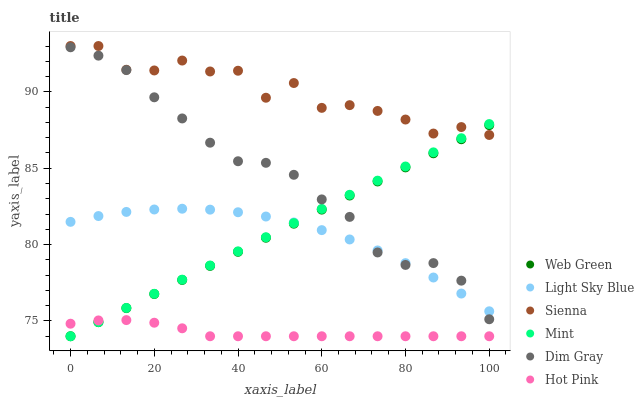Does Hot Pink have the minimum area under the curve?
Answer yes or no. Yes. Does Sienna have the maximum area under the curve?
Answer yes or no. Yes. Does Web Green have the minimum area under the curve?
Answer yes or no. No. Does Web Green have the maximum area under the curve?
Answer yes or no. No. Is Web Green the smoothest?
Answer yes or no. Yes. Is Sienna the roughest?
Answer yes or no. Yes. Is Hot Pink the smoothest?
Answer yes or no. No. Is Hot Pink the roughest?
Answer yes or no. No. Does Hot Pink have the lowest value?
Answer yes or no. Yes. Does Sienna have the lowest value?
Answer yes or no. No. Does Sienna have the highest value?
Answer yes or no. Yes. Does Web Green have the highest value?
Answer yes or no. No. Is Hot Pink less than Dim Gray?
Answer yes or no. Yes. Is Sienna greater than Hot Pink?
Answer yes or no. Yes. Does Web Green intersect Hot Pink?
Answer yes or no. Yes. Is Web Green less than Hot Pink?
Answer yes or no. No. Is Web Green greater than Hot Pink?
Answer yes or no. No. Does Hot Pink intersect Dim Gray?
Answer yes or no. No. 